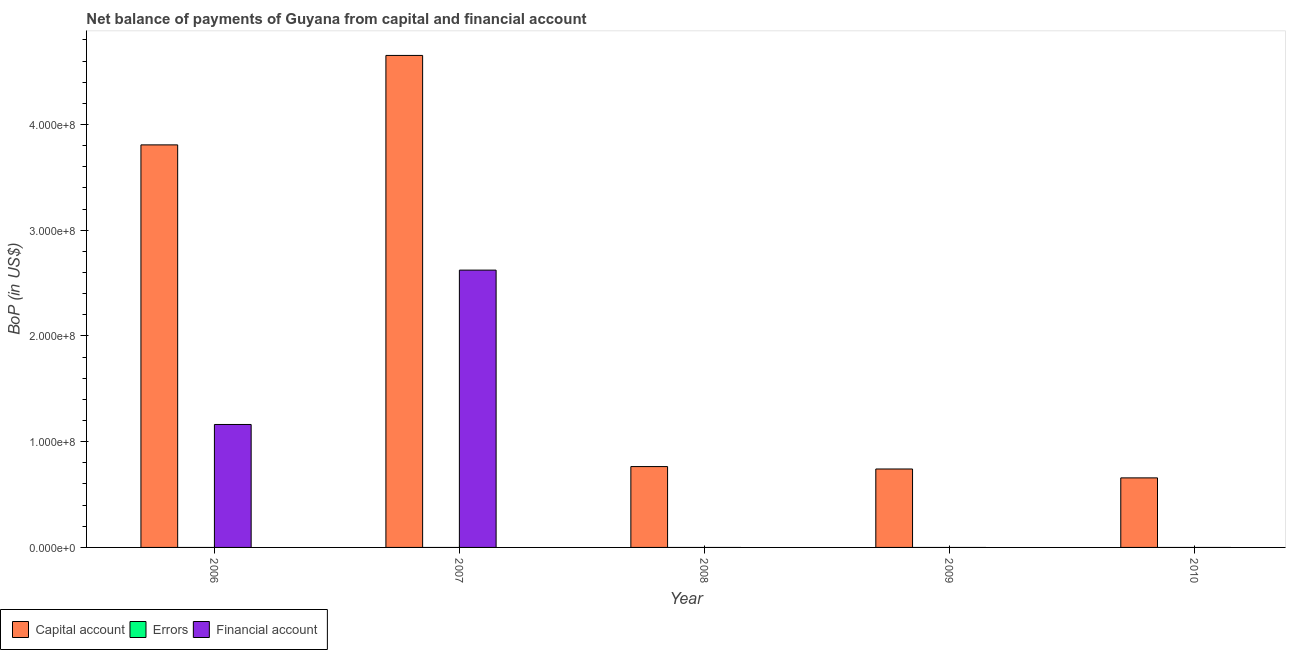How many different coloured bars are there?
Your answer should be very brief. 2. How many bars are there on the 4th tick from the left?
Ensure brevity in your answer.  1. How many bars are there on the 2nd tick from the right?
Your answer should be compact. 1. What is the label of the 5th group of bars from the left?
Your answer should be very brief. 2010. Across all years, what is the maximum amount of financial account?
Make the answer very short. 2.62e+08. In which year was the amount of net capital account maximum?
Your answer should be very brief. 2007. What is the total amount of net capital account in the graph?
Your answer should be very brief. 1.06e+09. What is the difference between the amount of financial account in 2006 and that in 2007?
Offer a terse response. -1.46e+08. What is the average amount of financial account per year?
Provide a short and direct response. 7.57e+07. In how many years, is the amount of errors greater than 400000000 US$?
Offer a very short reply. 0. What is the ratio of the amount of net capital account in 2006 to that in 2010?
Give a very brief answer. 5.79. Is the amount of net capital account in 2006 less than that in 2007?
Offer a terse response. Yes. What is the difference between the highest and the lowest amount of financial account?
Give a very brief answer. 2.62e+08. Is the sum of the amount of net capital account in 2006 and 2009 greater than the maximum amount of financial account across all years?
Offer a very short reply. No. How many bars are there?
Your response must be concise. 7. Does the graph contain grids?
Offer a very short reply. No. How are the legend labels stacked?
Your answer should be very brief. Horizontal. What is the title of the graph?
Your answer should be very brief. Net balance of payments of Guyana from capital and financial account. Does "Machinery" appear as one of the legend labels in the graph?
Offer a very short reply. No. What is the label or title of the X-axis?
Your answer should be very brief. Year. What is the label or title of the Y-axis?
Your response must be concise. BoP (in US$). What is the BoP (in US$) of Capital account in 2006?
Ensure brevity in your answer.  3.81e+08. What is the BoP (in US$) in Financial account in 2006?
Make the answer very short. 1.16e+08. What is the BoP (in US$) in Capital account in 2007?
Offer a very short reply. 4.65e+08. What is the BoP (in US$) in Financial account in 2007?
Ensure brevity in your answer.  2.62e+08. What is the BoP (in US$) of Capital account in 2008?
Ensure brevity in your answer.  7.65e+07. What is the BoP (in US$) in Errors in 2008?
Give a very brief answer. 0. What is the BoP (in US$) in Financial account in 2008?
Provide a succinct answer. 0. What is the BoP (in US$) of Capital account in 2009?
Offer a very short reply. 7.42e+07. What is the BoP (in US$) in Errors in 2009?
Provide a succinct answer. 0. What is the BoP (in US$) of Financial account in 2009?
Provide a succinct answer. 0. What is the BoP (in US$) in Capital account in 2010?
Keep it short and to the point. 6.58e+07. Across all years, what is the maximum BoP (in US$) in Capital account?
Ensure brevity in your answer.  4.65e+08. Across all years, what is the maximum BoP (in US$) of Financial account?
Provide a succinct answer. 2.62e+08. Across all years, what is the minimum BoP (in US$) in Capital account?
Keep it short and to the point. 6.58e+07. Across all years, what is the minimum BoP (in US$) in Financial account?
Provide a succinct answer. 0. What is the total BoP (in US$) of Capital account in the graph?
Keep it short and to the point. 1.06e+09. What is the total BoP (in US$) of Errors in the graph?
Offer a terse response. 0. What is the total BoP (in US$) in Financial account in the graph?
Provide a succinct answer. 3.79e+08. What is the difference between the BoP (in US$) in Capital account in 2006 and that in 2007?
Your response must be concise. -8.46e+07. What is the difference between the BoP (in US$) in Financial account in 2006 and that in 2007?
Provide a short and direct response. -1.46e+08. What is the difference between the BoP (in US$) in Capital account in 2006 and that in 2008?
Your answer should be very brief. 3.04e+08. What is the difference between the BoP (in US$) of Capital account in 2006 and that in 2009?
Ensure brevity in your answer.  3.07e+08. What is the difference between the BoP (in US$) in Capital account in 2006 and that in 2010?
Your response must be concise. 3.15e+08. What is the difference between the BoP (in US$) of Capital account in 2007 and that in 2008?
Your answer should be very brief. 3.89e+08. What is the difference between the BoP (in US$) in Capital account in 2007 and that in 2009?
Keep it short and to the point. 3.91e+08. What is the difference between the BoP (in US$) of Capital account in 2007 and that in 2010?
Your response must be concise. 4.00e+08. What is the difference between the BoP (in US$) of Capital account in 2008 and that in 2009?
Your response must be concise. 2.30e+06. What is the difference between the BoP (in US$) of Capital account in 2008 and that in 2010?
Offer a terse response. 1.07e+07. What is the difference between the BoP (in US$) in Capital account in 2009 and that in 2010?
Give a very brief answer. 8.40e+06. What is the difference between the BoP (in US$) of Capital account in 2006 and the BoP (in US$) of Financial account in 2007?
Provide a short and direct response. 1.18e+08. What is the average BoP (in US$) of Capital account per year?
Ensure brevity in your answer.  2.12e+08. What is the average BoP (in US$) of Financial account per year?
Provide a short and direct response. 7.57e+07. In the year 2006, what is the difference between the BoP (in US$) of Capital account and BoP (in US$) of Financial account?
Your answer should be very brief. 2.64e+08. In the year 2007, what is the difference between the BoP (in US$) of Capital account and BoP (in US$) of Financial account?
Ensure brevity in your answer.  2.03e+08. What is the ratio of the BoP (in US$) in Capital account in 2006 to that in 2007?
Ensure brevity in your answer.  0.82. What is the ratio of the BoP (in US$) in Financial account in 2006 to that in 2007?
Your answer should be compact. 0.44. What is the ratio of the BoP (in US$) in Capital account in 2006 to that in 2008?
Ensure brevity in your answer.  4.98. What is the ratio of the BoP (in US$) of Capital account in 2006 to that in 2009?
Ensure brevity in your answer.  5.13. What is the ratio of the BoP (in US$) of Capital account in 2006 to that in 2010?
Offer a terse response. 5.79. What is the ratio of the BoP (in US$) in Capital account in 2007 to that in 2008?
Offer a terse response. 6.08. What is the ratio of the BoP (in US$) in Capital account in 2007 to that in 2009?
Your answer should be compact. 6.27. What is the ratio of the BoP (in US$) of Capital account in 2007 to that in 2010?
Keep it short and to the point. 7.07. What is the ratio of the BoP (in US$) in Capital account in 2008 to that in 2009?
Your response must be concise. 1.03. What is the ratio of the BoP (in US$) in Capital account in 2008 to that in 2010?
Offer a very short reply. 1.16. What is the ratio of the BoP (in US$) in Capital account in 2009 to that in 2010?
Offer a terse response. 1.13. What is the difference between the highest and the second highest BoP (in US$) in Capital account?
Your answer should be compact. 8.46e+07. What is the difference between the highest and the lowest BoP (in US$) of Capital account?
Provide a succinct answer. 4.00e+08. What is the difference between the highest and the lowest BoP (in US$) in Financial account?
Your response must be concise. 2.62e+08. 